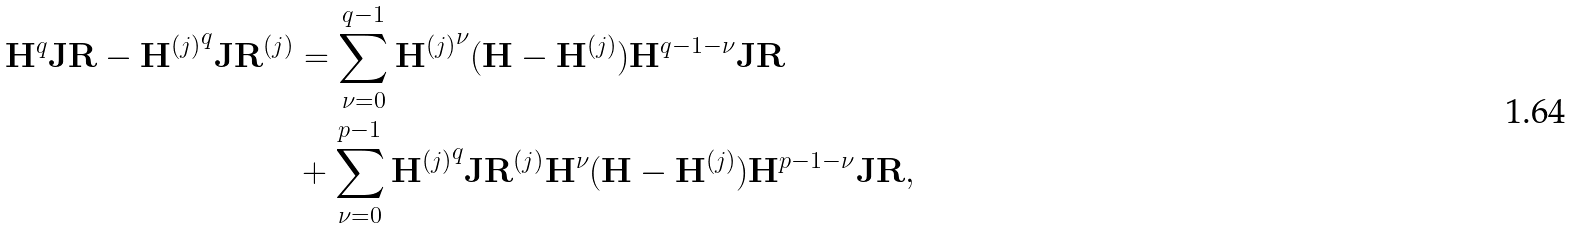Convert formula to latex. <formula><loc_0><loc_0><loc_500><loc_500>\mathbf H ^ { q } \mathbf J \mathbf R - { \mathbf H ^ { ( j ) } } ^ { q } \mathbf J \mathbf R ^ { ( j ) } & = \sum _ { \nu = 0 } ^ { q - 1 } { \mathbf H ^ { ( j ) } } ^ { \nu } ( \mathbf H - \mathbf H ^ { ( j ) } ) { \mathbf H } ^ { q - 1 - \nu } \mathbf J \mathbf R \\ & + \sum _ { \nu = 0 } ^ { p - 1 } { \mathbf H ^ { ( j ) } } ^ { q } \mathbf J \mathbf R ^ { ( j ) } \mathbf H ^ { \nu } ( \mathbf H - \mathbf H ^ { ( j ) } ) \mathbf H ^ { p - 1 - \nu } \mathbf J \mathbf R ,</formula> 